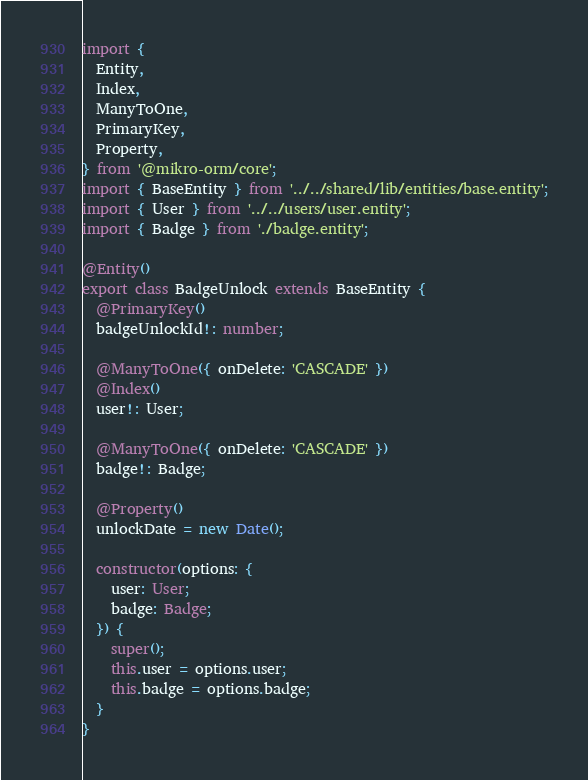Convert code to text. <code><loc_0><loc_0><loc_500><loc_500><_TypeScript_>import {
  Entity,
  Index,
  ManyToOne,
  PrimaryKey,
  Property,
} from '@mikro-orm/core';
import { BaseEntity } from '../../shared/lib/entities/base.entity';
import { User } from '../../users/user.entity';
import { Badge } from './badge.entity';

@Entity()
export class BadgeUnlock extends BaseEntity {
  @PrimaryKey()
  badgeUnlockId!: number;

  @ManyToOne({ onDelete: 'CASCADE' })
  @Index()
  user!: User;

  @ManyToOne({ onDelete: 'CASCADE' })
  badge!: Badge;

  @Property()
  unlockDate = new Date();

  constructor(options: {
    user: User;
    badge: Badge;
  }) {
    super();
    this.user = options.user;
    this.badge = options.badge;
  }
}
</code> 